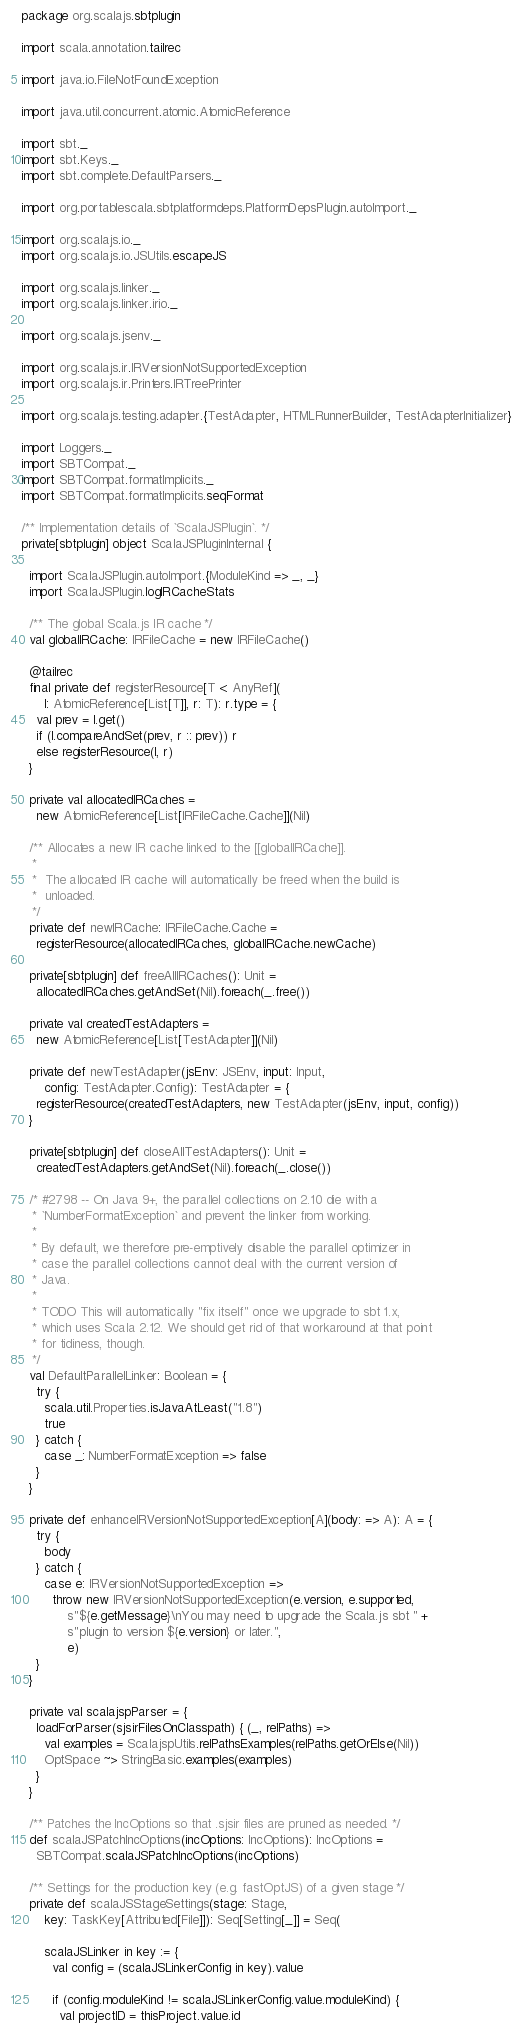Convert code to text. <code><loc_0><loc_0><loc_500><loc_500><_Scala_>package org.scalajs.sbtplugin

import scala.annotation.tailrec

import java.io.FileNotFoundException

import java.util.concurrent.atomic.AtomicReference

import sbt._
import sbt.Keys._
import sbt.complete.DefaultParsers._

import org.portablescala.sbtplatformdeps.PlatformDepsPlugin.autoImport._

import org.scalajs.io._
import org.scalajs.io.JSUtils.escapeJS

import org.scalajs.linker._
import org.scalajs.linker.irio._

import org.scalajs.jsenv._

import org.scalajs.ir.IRVersionNotSupportedException
import org.scalajs.ir.Printers.IRTreePrinter

import org.scalajs.testing.adapter.{TestAdapter, HTMLRunnerBuilder, TestAdapterInitializer}

import Loggers._
import SBTCompat._
import SBTCompat.formatImplicits._
import SBTCompat.formatImplicits.seqFormat

/** Implementation details of `ScalaJSPlugin`. */
private[sbtplugin] object ScalaJSPluginInternal {

  import ScalaJSPlugin.autoImport.{ModuleKind => _, _}
  import ScalaJSPlugin.logIRCacheStats

  /** The global Scala.js IR cache */
  val globalIRCache: IRFileCache = new IRFileCache()

  @tailrec
  final private def registerResource[T <: AnyRef](
      l: AtomicReference[List[T]], r: T): r.type = {
    val prev = l.get()
    if (l.compareAndSet(prev, r :: prev)) r
    else registerResource(l, r)
  }

  private val allocatedIRCaches =
    new AtomicReference[List[IRFileCache.Cache]](Nil)

  /** Allocates a new IR cache linked to the [[globalIRCache]].
   *
   *  The allocated IR cache will automatically be freed when the build is
   *  unloaded.
   */
  private def newIRCache: IRFileCache.Cache =
    registerResource(allocatedIRCaches, globalIRCache.newCache)

  private[sbtplugin] def freeAllIRCaches(): Unit =
    allocatedIRCaches.getAndSet(Nil).foreach(_.free())

  private val createdTestAdapters =
    new AtomicReference[List[TestAdapter]](Nil)

  private def newTestAdapter(jsEnv: JSEnv, input: Input,
      config: TestAdapter.Config): TestAdapter = {
    registerResource(createdTestAdapters, new TestAdapter(jsEnv, input, config))
  }

  private[sbtplugin] def closeAllTestAdapters(): Unit =
    createdTestAdapters.getAndSet(Nil).foreach(_.close())

  /* #2798 -- On Java 9+, the parallel collections on 2.10 die with a
   * `NumberFormatException` and prevent the linker from working.
   *
   * By default, we therefore pre-emptively disable the parallel optimizer in
   * case the parallel collections cannot deal with the current version of
   * Java.
   *
   * TODO This will automatically "fix itself" once we upgrade to sbt 1.x,
   * which uses Scala 2.12. We should get rid of that workaround at that point
   * for tidiness, though.
   */
  val DefaultParallelLinker: Boolean = {
    try {
      scala.util.Properties.isJavaAtLeast("1.8")
      true
    } catch {
      case _: NumberFormatException => false
    }
  }

  private def enhanceIRVersionNotSupportedException[A](body: => A): A = {
    try {
      body
    } catch {
      case e: IRVersionNotSupportedException =>
        throw new IRVersionNotSupportedException(e.version, e.supported,
            s"${e.getMessage}\nYou may need to upgrade the Scala.js sbt " +
            s"plugin to version ${e.version} or later.",
            e)
    }
  }

  private val scalajspParser = {
    loadForParser(sjsirFilesOnClasspath) { (_, relPaths) =>
      val examples = ScalajspUtils.relPathsExamples(relPaths.getOrElse(Nil))
      OptSpace ~> StringBasic.examples(examples)
    }
  }

  /** Patches the IncOptions so that .sjsir files are pruned as needed. */
  def scalaJSPatchIncOptions(incOptions: IncOptions): IncOptions =
    SBTCompat.scalaJSPatchIncOptions(incOptions)

  /** Settings for the production key (e.g. fastOptJS) of a given stage */
  private def scalaJSStageSettings(stage: Stage,
      key: TaskKey[Attributed[File]]): Seq[Setting[_]] = Seq(

      scalaJSLinker in key := {
        val config = (scalaJSLinkerConfig in key).value

        if (config.moduleKind != scalaJSLinkerConfig.value.moduleKind) {
          val projectID = thisProject.value.id</code> 